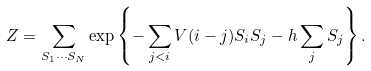Convert formula to latex. <formula><loc_0><loc_0><loc_500><loc_500>Z = \sum _ { S _ { 1 } \cdots S _ { N } } \exp \left \{ - \sum _ { j < i } V ( i - j ) S _ { i } S _ { j } - h \sum _ { j } S _ { j } \right \} .</formula> 